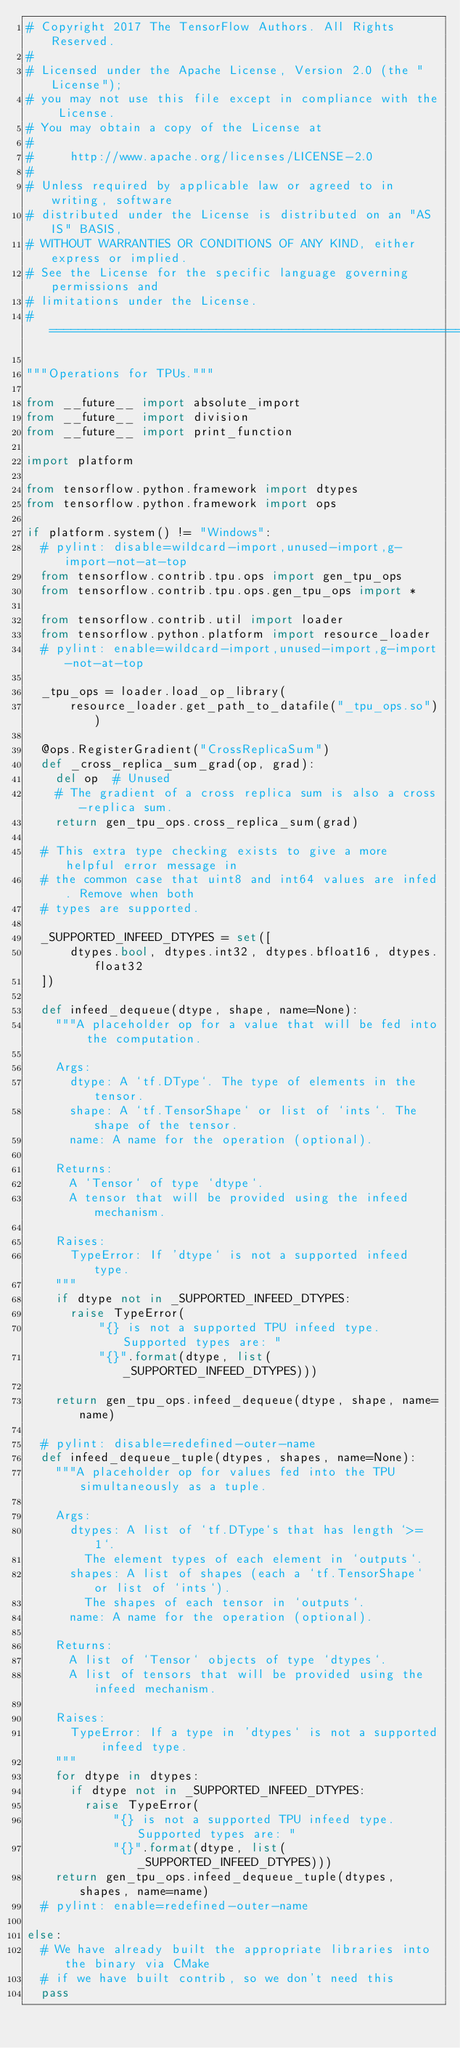Convert code to text. <code><loc_0><loc_0><loc_500><loc_500><_Python_># Copyright 2017 The TensorFlow Authors. All Rights Reserved.
#
# Licensed under the Apache License, Version 2.0 (the "License");
# you may not use this file except in compliance with the License.
# You may obtain a copy of the License at
#
#     http://www.apache.org/licenses/LICENSE-2.0
#
# Unless required by applicable law or agreed to in writing, software
# distributed under the License is distributed on an "AS IS" BASIS,
# WITHOUT WARRANTIES OR CONDITIONS OF ANY KIND, either express or implied.
# See the License for the specific language governing permissions and
# limitations under the License.
# =============================================================================

"""Operations for TPUs."""

from __future__ import absolute_import
from __future__ import division
from __future__ import print_function

import platform

from tensorflow.python.framework import dtypes
from tensorflow.python.framework import ops

if platform.system() != "Windows":
  # pylint: disable=wildcard-import,unused-import,g-import-not-at-top
  from tensorflow.contrib.tpu.ops import gen_tpu_ops
  from tensorflow.contrib.tpu.ops.gen_tpu_ops import *

  from tensorflow.contrib.util import loader
  from tensorflow.python.platform import resource_loader
  # pylint: enable=wildcard-import,unused-import,g-import-not-at-top

  _tpu_ops = loader.load_op_library(
      resource_loader.get_path_to_datafile("_tpu_ops.so"))

  @ops.RegisterGradient("CrossReplicaSum")
  def _cross_replica_sum_grad(op, grad):
    del op  # Unused
    # The gradient of a cross replica sum is also a cross-replica sum.
    return gen_tpu_ops.cross_replica_sum(grad)

  # This extra type checking exists to give a more helpful error message in
  # the common case that uint8 and int64 values are infed. Remove when both
  # types are supported.

  _SUPPORTED_INFEED_DTYPES = set([
      dtypes.bool, dtypes.int32, dtypes.bfloat16, dtypes.float32
  ])

  def infeed_dequeue(dtype, shape, name=None):
    """A placeholder op for a value that will be fed into the computation.

    Args:
      dtype: A `tf.DType`. The type of elements in the tensor.
      shape: A `tf.TensorShape` or list of `ints`. The shape of the tensor.
      name: A name for the operation (optional).

    Returns:
      A `Tensor` of type `dtype`.
      A tensor that will be provided using the infeed mechanism.

    Raises:
      TypeError: If 'dtype` is not a supported infeed type.
    """
    if dtype not in _SUPPORTED_INFEED_DTYPES:
      raise TypeError(
          "{} is not a supported TPU infeed type. Supported types are: "
          "{}".format(dtype, list(_SUPPORTED_INFEED_DTYPES)))

    return gen_tpu_ops.infeed_dequeue(dtype, shape, name=name)

  # pylint: disable=redefined-outer-name
  def infeed_dequeue_tuple(dtypes, shapes, name=None):
    """A placeholder op for values fed into the TPU simultaneously as a tuple.

    Args:
      dtypes: A list of `tf.DType`s that has length `>= 1`.
        The element types of each element in `outputs`.
      shapes: A list of shapes (each a `tf.TensorShape` or list of `ints`).
        The shapes of each tensor in `outputs`.
      name: A name for the operation (optional).

    Returns:
      A list of `Tensor` objects of type `dtypes`.
      A list of tensors that will be provided using the infeed mechanism.

    Raises:
      TypeError: If a type in 'dtypes` is not a supported infeed type.
    """
    for dtype in dtypes:
      if dtype not in _SUPPORTED_INFEED_DTYPES:
        raise TypeError(
            "{} is not a supported TPU infeed type. Supported types are: "
            "{}".format(dtype, list(_SUPPORTED_INFEED_DTYPES)))
    return gen_tpu_ops.infeed_dequeue_tuple(dtypes, shapes, name=name)
  # pylint: enable=redefined-outer-name

else:
  # We have already built the appropriate libraries into the binary via CMake
  # if we have built contrib, so we don't need this
  pass
</code> 